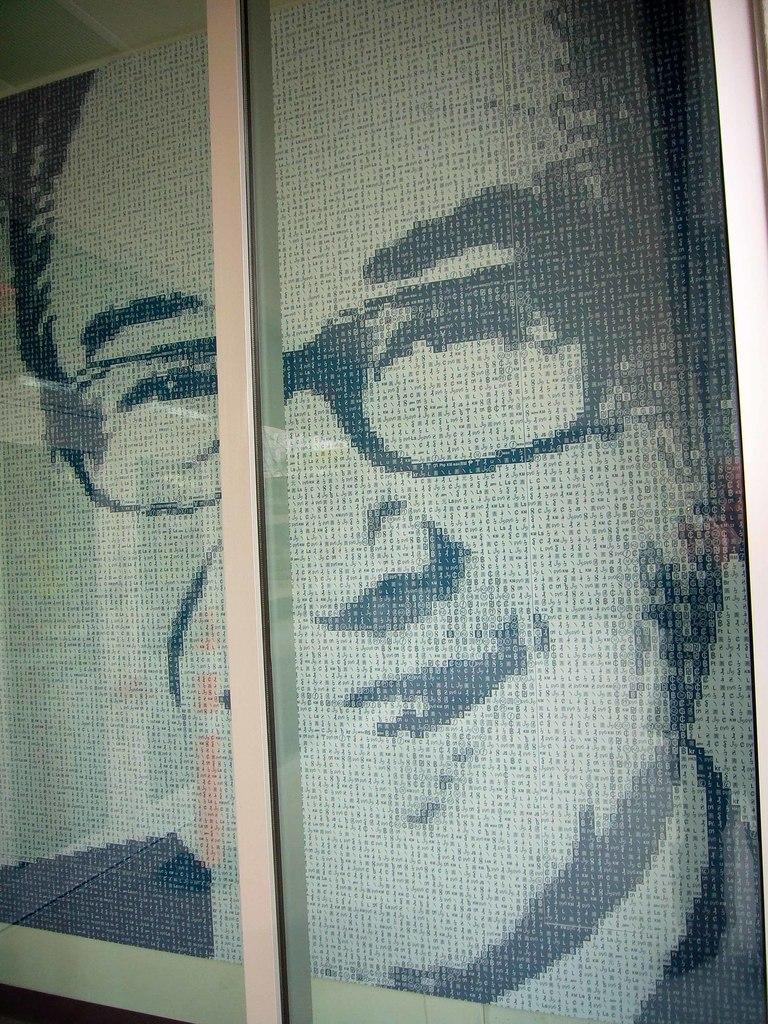What is depicted on the wall in the image? There is a picture of a person on the wall in the image. What type of animal can be seen swimming with the ducks in the image? There are no animals or ducks present in the image; it only features a picture of a person on the wall. 